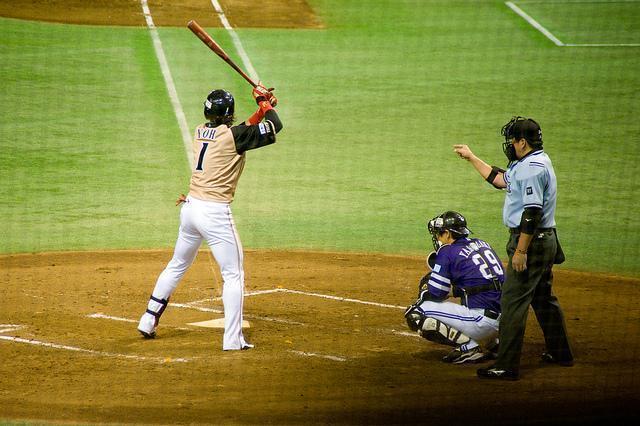Why is the guy in purple crouching?
Choose the correct response, then elucidate: 'Answer: answer
Rationale: rationale.'
Options: Referee, injured, catcher's stance, fielding ball. Answer: catcher's stance.
Rationale: The guy in purple is in the crouch position so that he can catch the ball when it is thrown by the pitcher across the plate. 